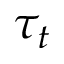Convert formula to latex. <formula><loc_0><loc_0><loc_500><loc_500>\tau _ { t }</formula> 